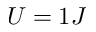<formula> <loc_0><loc_0><loc_500><loc_500>U = 1 J</formula> 